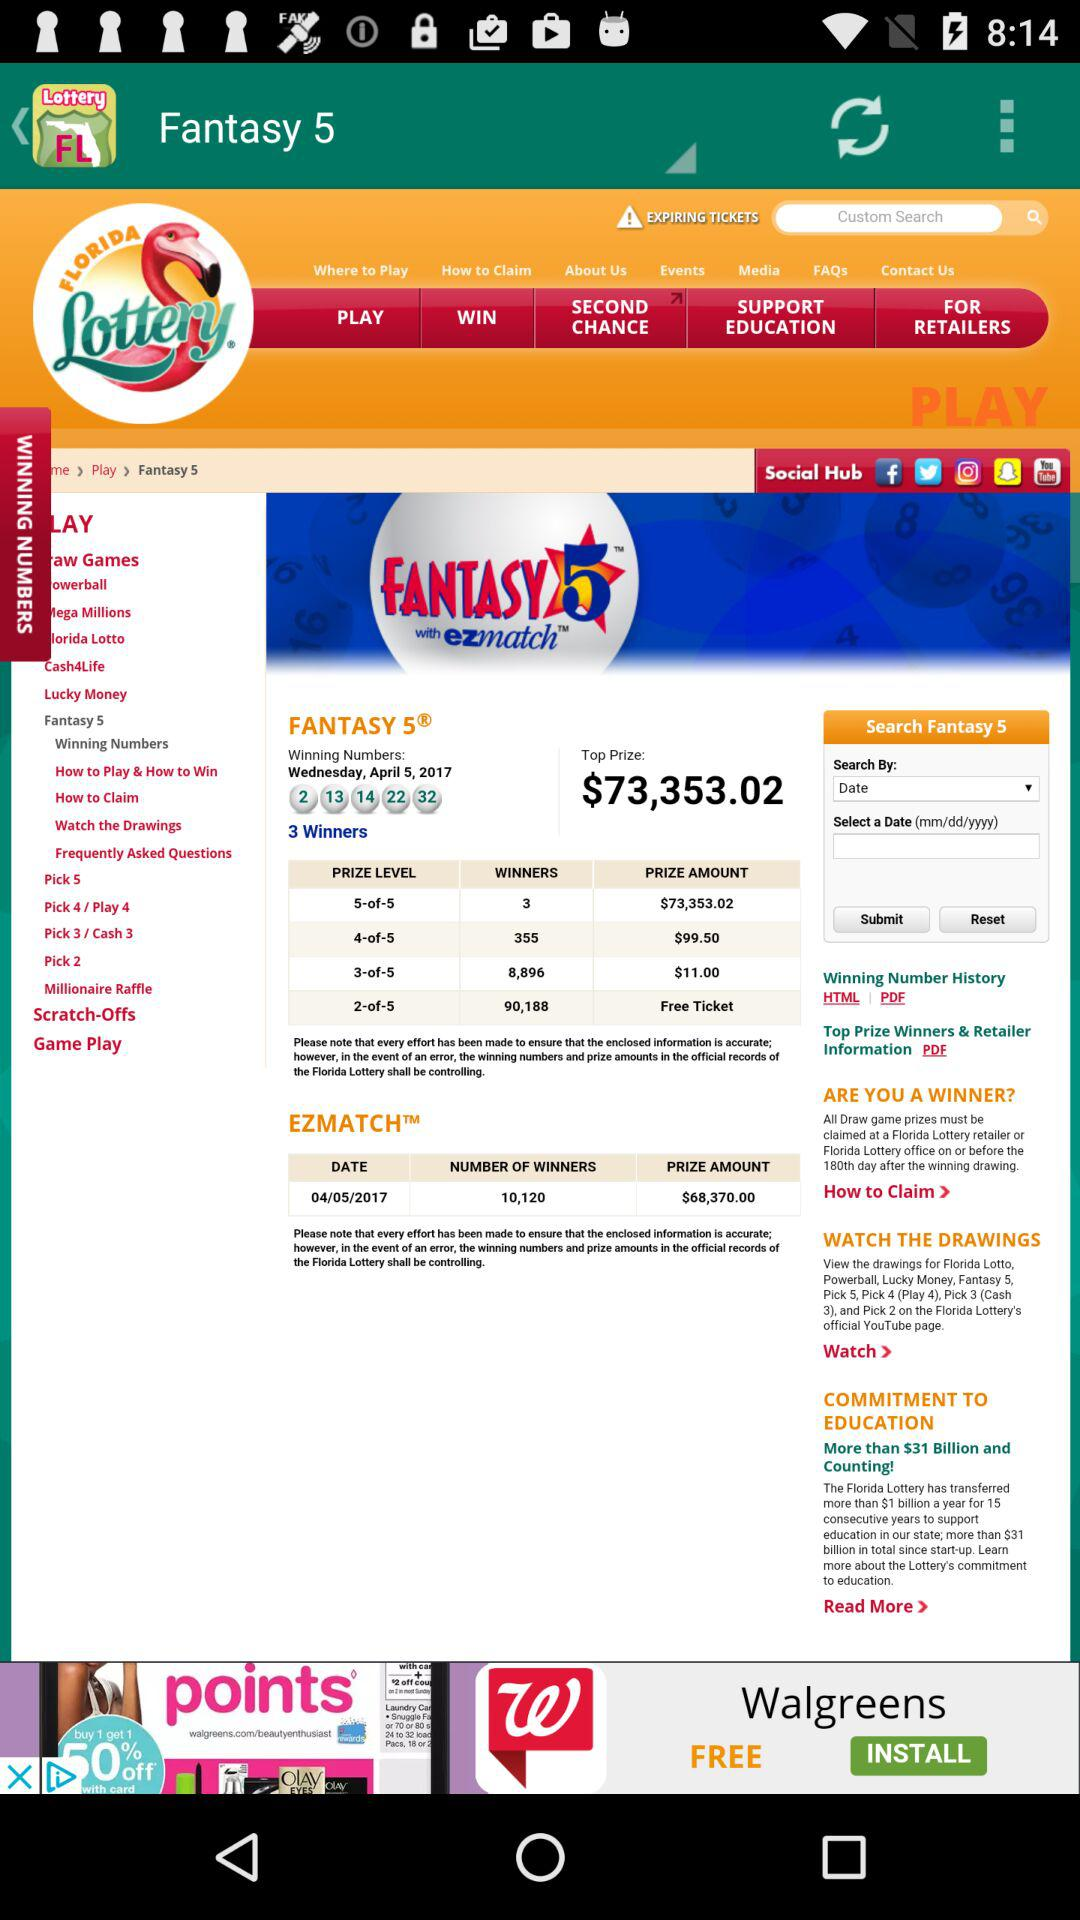What is the top prize in "Fantasy 5"? The top prize in "Fantasy 5" is $73,353.02. 